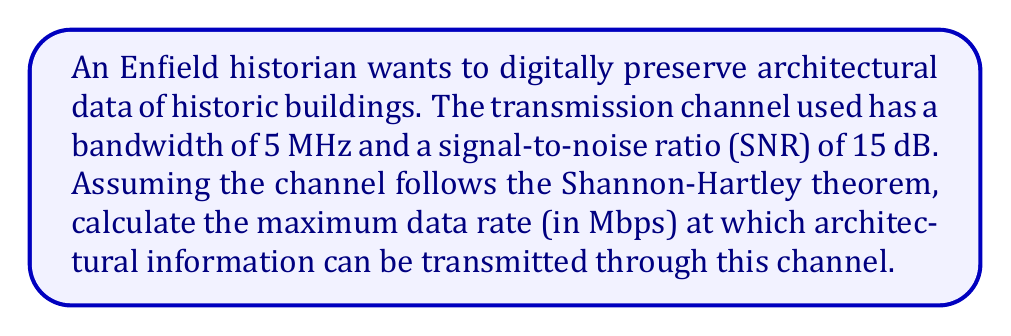Give your solution to this math problem. To solve this problem, we'll use the Shannon-Hartley theorem, which gives the channel capacity for a communications channel subject to Gaussian noise. The theorem is expressed as:

$$C = B \log_2(1 + SNR)$$

Where:
$C$ = Channel capacity (bits per second)
$B$ = Bandwidth of the channel (Hz)
$SNR$ = Signal-to-noise ratio (linear scale, not dB)

Given:
- Bandwidth $(B) = 5$ MHz $= 5 \times 10^6$ Hz
- SNR $= 15$ dB

Step 1: Convert SNR from dB to linear scale
$$SNR_{linear} = 10^{\frac{SNR_{dB}}{10}} = 10^{\frac{15}{10}} = 10^{1.5} \approx 31.6228$$

Step 2: Apply the Shannon-Hartley theorem
$$\begin{align}
C &= B \log_2(1 + SNR) \\
&= (5 \times 10^6) \log_2(1 + 31.6228) \\
&= (5 \times 10^6) \log_2(32.6228) \\
&\approx (5 \times 10^6) (5.0279) \\
&\approx 25.1395 \times 10^6 \text{ bits per second}
\end{align}$$

Step 3: Convert bits per second to Megabits per second (Mbps)
$$25.1395 \times 10^6 \text{ bps} = 25.1395 \text{ Mbps}$$

Therefore, the maximum data rate at which architectural information can be transmitted through this channel is approximately 25.1395 Mbps.
Answer: 25.1395 Mbps 